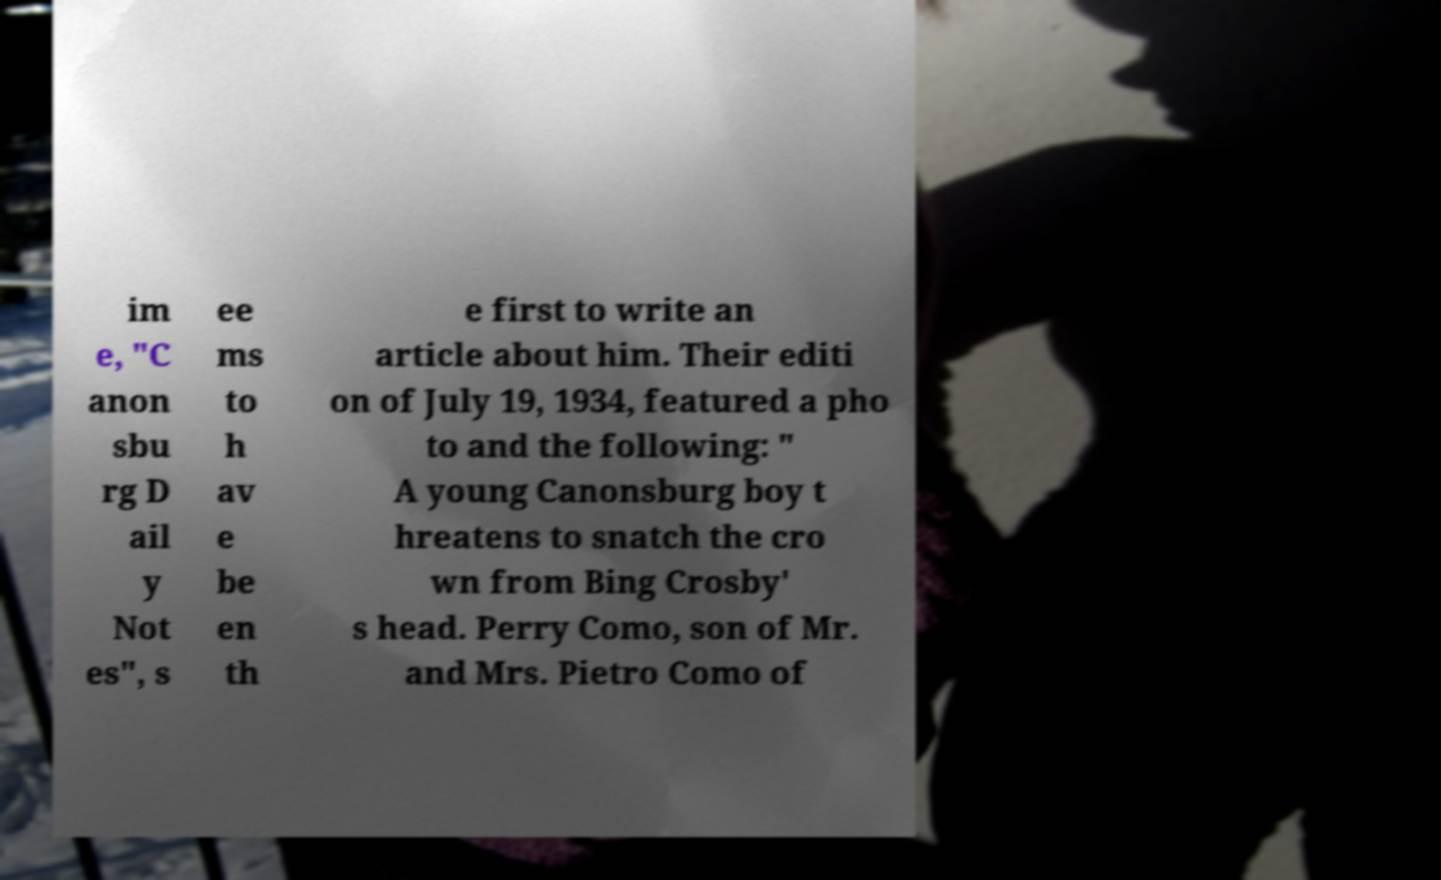Please read and relay the text visible in this image. What does it say? im e, "C anon sbu rg D ail y Not es", s ee ms to h av e be en th e first to write an article about him. Their editi on of July 19, 1934, featured a pho to and the following: " A young Canonsburg boy t hreatens to snatch the cro wn from Bing Crosby' s head. Perry Como, son of Mr. and Mrs. Pietro Como of 